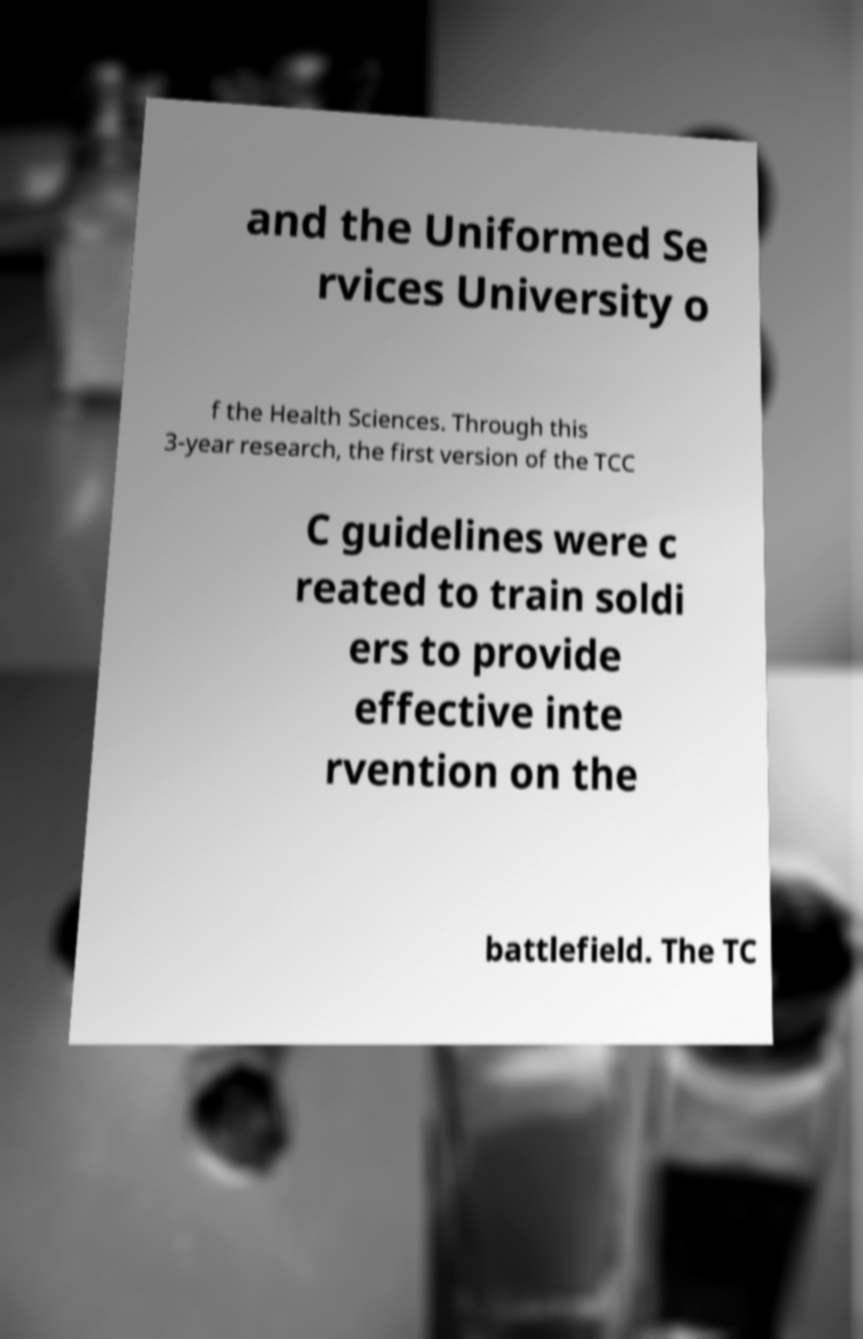Please read and relay the text visible in this image. What does it say? and the Uniformed Se rvices University o f the Health Sciences. Through this 3-year research, the first version of the TCC C guidelines were c reated to train soldi ers to provide effective inte rvention on the battlefield. The TC 